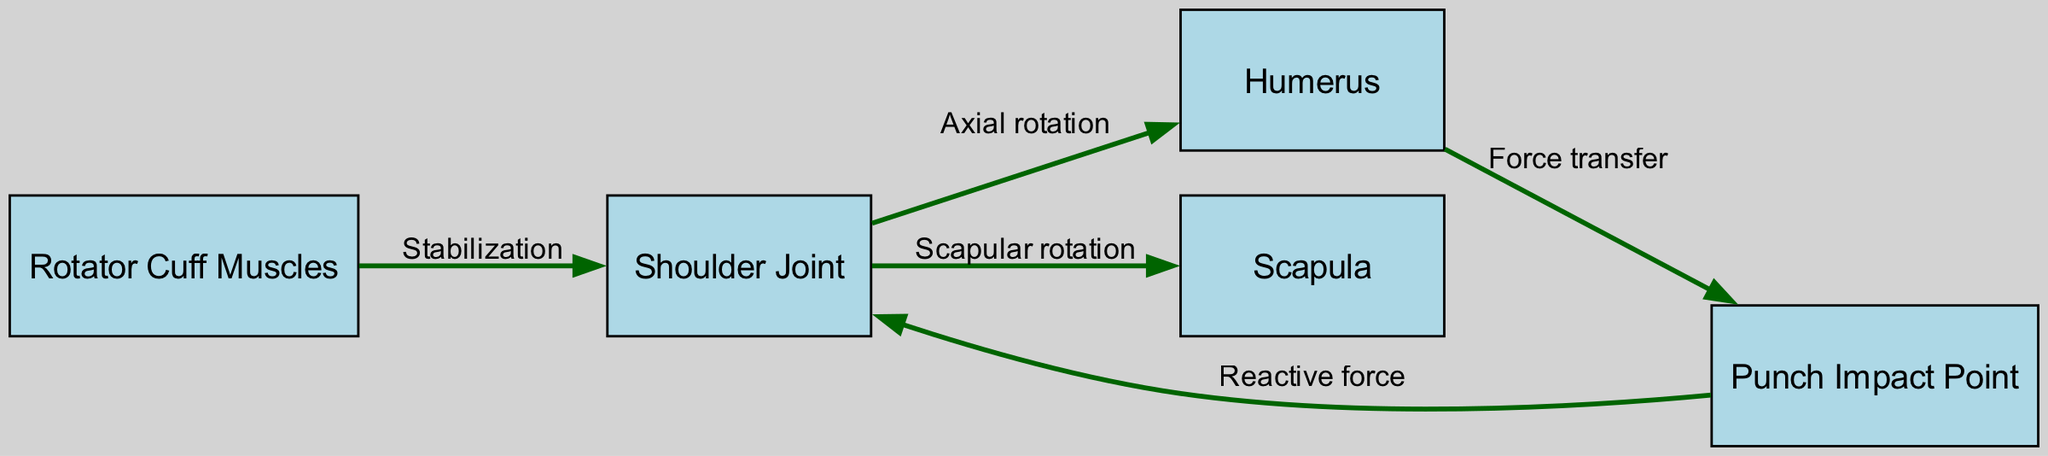What is the total number of nodes in the diagram? The diagram has five nodes: Shoulder Joint, Humerus, Scapula, Rotator Cuff Muscles, and Punch Impact Point. Therefore, adding these together gives a total of five nodes.
Answer: 5 What force is responsible for stabilization at the shoulder joint? In the diagram, the Rotator Cuff Muscles are connected to the Shoulder Joint with a label indicating "Stabilization," implying that they play a key role in stabilizing the shoulder joint during movement.
Answer: Rotator Cuff Muscles What type of rotation is indicated from the Shoulder Joint to the Humerus? The edge connecting the Shoulder Joint to the Humerus is labeled "Axial rotation," which describes the type of rotational movement that occurs at this joint when throwing a punch.
Answer: Axial rotation How many directed edges are present in the diagram? There are five edges in the diagram connecting the various nodes: one from Shoulder Joint to Humerus, one from Shoulder Joint to Scapula, one from Rotator Cuff to Shoulder Joint, one from Humerus to Punch Impact Point, and one from Punch Impact Point to Shoulder Joint. Therefore, the total is five edges.
Answer: 5 Which node is the point where the force from the punch is transferred? The diagram shows an edge labeled "Force transfer" going from the Humerus to the Punch Impact Point, indicating that the Humerus is the bone through which the force is transmitted upon impact during a punch.
Answer: Punch Impact Point What is the nature of the force indicated from the Punch Impact Point back to the Shoulder Joint? The edge from the Punch Impact Point to the Shoulder Joint is labeled "Reactive force," which indicates that this force acts upon the shoulder joint in response to the impact during a punch.
Answer: Reactive force What type of rotation occurs between the Shoulder Joint and the Scapula? The arrow between the Shoulder Joint and the Scapula is labeled "Scapular rotation," indicating that this type of rotation involves the movement of the scapula in conjunction with shoulder movements.
Answer: Scapular rotation What is the primary function of the Rotator Cuff Muscles in this diagram? The Rotator Cuff Muscles are designated as providing "Stabilization" to the Shoulder Joint, which serves to maintain joint stability during dynamic movements like punching.
Answer: Stabilization 